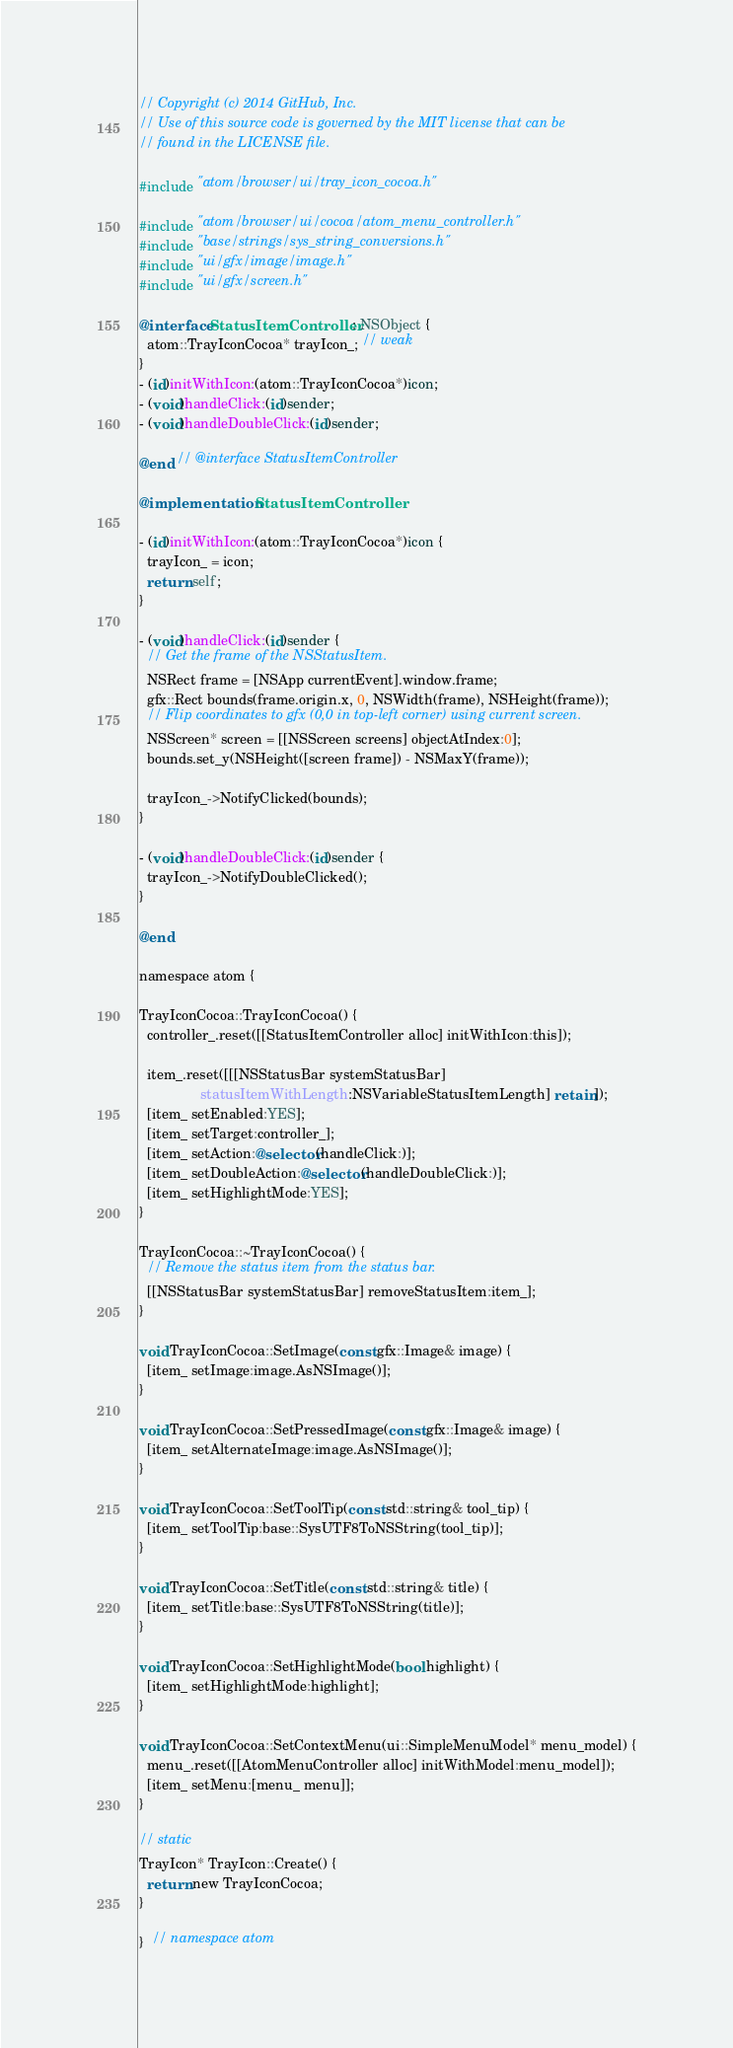<code> <loc_0><loc_0><loc_500><loc_500><_ObjectiveC_>// Copyright (c) 2014 GitHub, Inc.
// Use of this source code is governed by the MIT license that can be
// found in the LICENSE file.

#include "atom/browser/ui/tray_icon_cocoa.h"

#include "atom/browser/ui/cocoa/atom_menu_controller.h"
#include "base/strings/sys_string_conversions.h"
#include "ui/gfx/image/image.h"
#include "ui/gfx/screen.h"

@interface StatusItemController : NSObject {
  atom::TrayIconCocoa* trayIcon_; // weak
}
- (id)initWithIcon:(atom::TrayIconCocoa*)icon;
- (void)handleClick:(id)sender;
- (void)handleDoubleClick:(id)sender;

@end // @interface StatusItemController

@implementation StatusItemController

- (id)initWithIcon:(atom::TrayIconCocoa*)icon {
  trayIcon_ = icon;
  return self;
}

- (void)handleClick:(id)sender {
  // Get the frame of the NSStatusItem.
  NSRect frame = [NSApp currentEvent].window.frame;
  gfx::Rect bounds(frame.origin.x, 0, NSWidth(frame), NSHeight(frame));
  // Flip coordinates to gfx (0,0 in top-left corner) using current screen.
  NSScreen* screen = [[NSScreen screens] objectAtIndex:0];
  bounds.set_y(NSHeight([screen frame]) - NSMaxY(frame));

  trayIcon_->NotifyClicked(bounds);
}

- (void)handleDoubleClick:(id)sender {
  trayIcon_->NotifyDoubleClicked();
}

@end

namespace atom {

TrayIconCocoa::TrayIconCocoa() {
  controller_.reset([[StatusItemController alloc] initWithIcon:this]);

  item_.reset([[[NSStatusBar systemStatusBar]
                statusItemWithLength:NSVariableStatusItemLength] retain]);
  [item_ setEnabled:YES];
  [item_ setTarget:controller_];
  [item_ setAction:@selector(handleClick:)];
  [item_ setDoubleAction:@selector(handleDoubleClick:)];
  [item_ setHighlightMode:YES];
}

TrayIconCocoa::~TrayIconCocoa() {
  // Remove the status item from the status bar.
  [[NSStatusBar systemStatusBar] removeStatusItem:item_];
}

void TrayIconCocoa::SetImage(const gfx::Image& image) {
  [item_ setImage:image.AsNSImage()];
}

void TrayIconCocoa::SetPressedImage(const gfx::Image& image) {
  [item_ setAlternateImage:image.AsNSImage()];
}

void TrayIconCocoa::SetToolTip(const std::string& tool_tip) {
  [item_ setToolTip:base::SysUTF8ToNSString(tool_tip)];
}

void TrayIconCocoa::SetTitle(const std::string& title) {
  [item_ setTitle:base::SysUTF8ToNSString(title)];
}

void TrayIconCocoa::SetHighlightMode(bool highlight) {
  [item_ setHighlightMode:highlight];
}

void TrayIconCocoa::SetContextMenu(ui::SimpleMenuModel* menu_model) {
  menu_.reset([[AtomMenuController alloc] initWithModel:menu_model]);
  [item_ setMenu:[menu_ menu]];
}

// static
TrayIcon* TrayIcon::Create() {
  return new TrayIconCocoa;
}

}  // namespace atom
</code> 